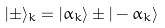<formula> <loc_0><loc_0><loc_500><loc_500>| \pm \rangle _ { k } = | \alpha _ { k } \rangle \pm | - \alpha _ { k } \rangle</formula> 